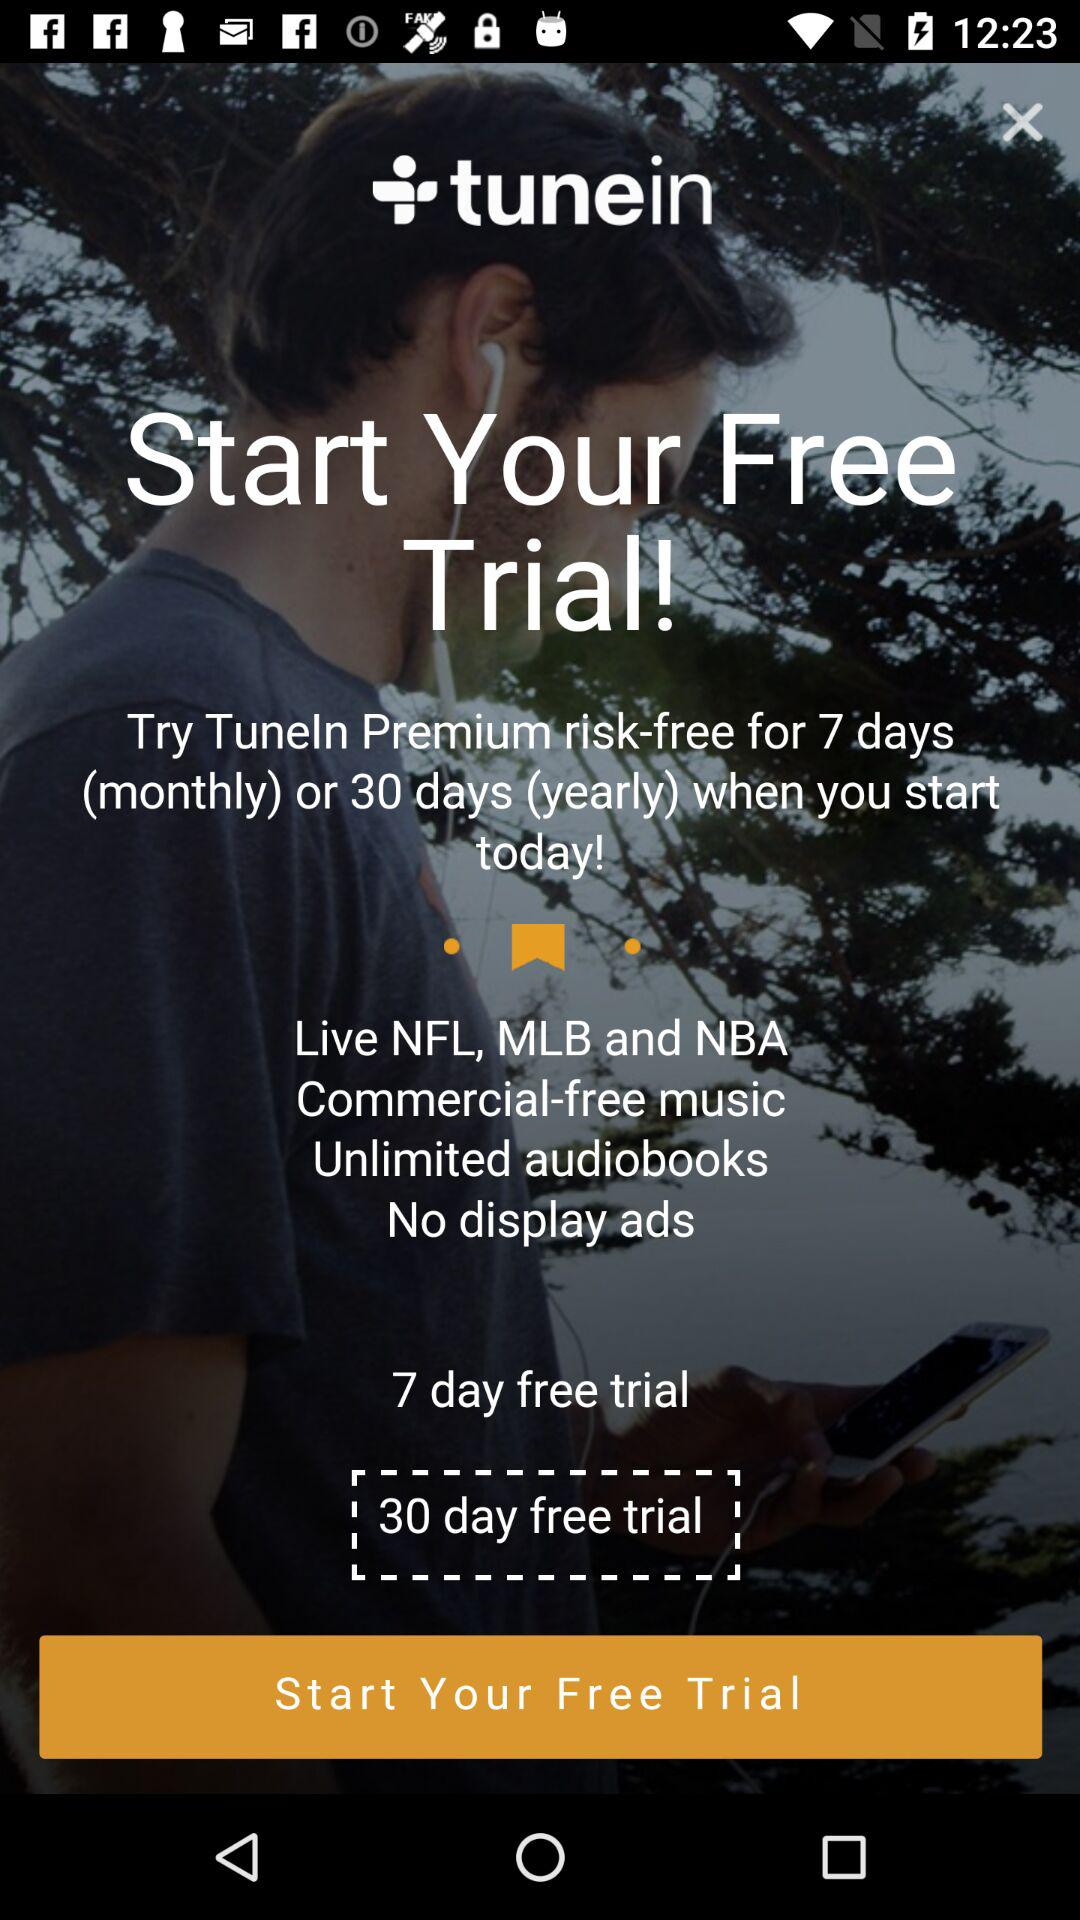What are the features of the free trial? The features are live NFL, MLB and NBA, commercial-free music, unlimited audiobooks and no display ads. 